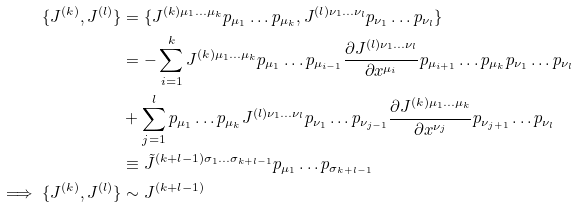<formula> <loc_0><loc_0><loc_500><loc_500>\{ J ^ { ( k ) } , J ^ { ( l ) } \} & = \{ J ^ { ( k ) \mu _ { 1 } \dots \mu _ { k } } p _ { \mu _ { 1 } } \dots p _ { \mu _ { k } } , J ^ { ( l ) \nu _ { 1 } \dots \nu _ { l } } p _ { \nu _ { 1 } } \dots p _ { \nu _ { l } } \} \\ & = - \sum _ { i = 1 } ^ { k } J ^ { ( k ) \mu _ { 1 } \dots \mu _ { k } } p _ { \mu _ { 1 } } \dots p _ { \mu _ { i - 1 } } \frac { \partial J ^ { ( l ) \nu _ { 1 } \dots \nu _ { l } } } { \partial x ^ { \mu _ { i } } } p _ { \mu _ { i + 1 } } \dots p _ { \mu _ { k } } p _ { \nu _ { 1 } } \dots p _ { \nu _ { l } } \\ & + \sum _ { j = 1 } ^ { l } p _ { \mu _ { 1 } } \dots p _ { \mu _ { k } } J ^ { ( l ) \nu _ { 1 } \dots \nu _ { l } } p _ { \nu _ { 1 } } \dots p _ { \nu _ { j - 1 } } \frac { \partial J ^ { ( k ) \mu _ { 1 } \dots \mu _ { k } } } { \partial x ^ { \nu _ { j } } } p _ { \nu _ { j + 1 } } \dots p _ { \nu _ { l } } \\ & \equiv \tilde { J } ^ { ( k + l - 1 ) \sigma _ { 1 } \dots \sigma _ { k + l - 1 } } p _ { \mu _ { 1 } } \dots p _ { \sigma _ { k + l - 1 } } \\ \implies \{ J ^ { ( k ) } , J ^ { ( l ) } \} & \sim J ^ { ( k + l - 1 ) }</formula> 